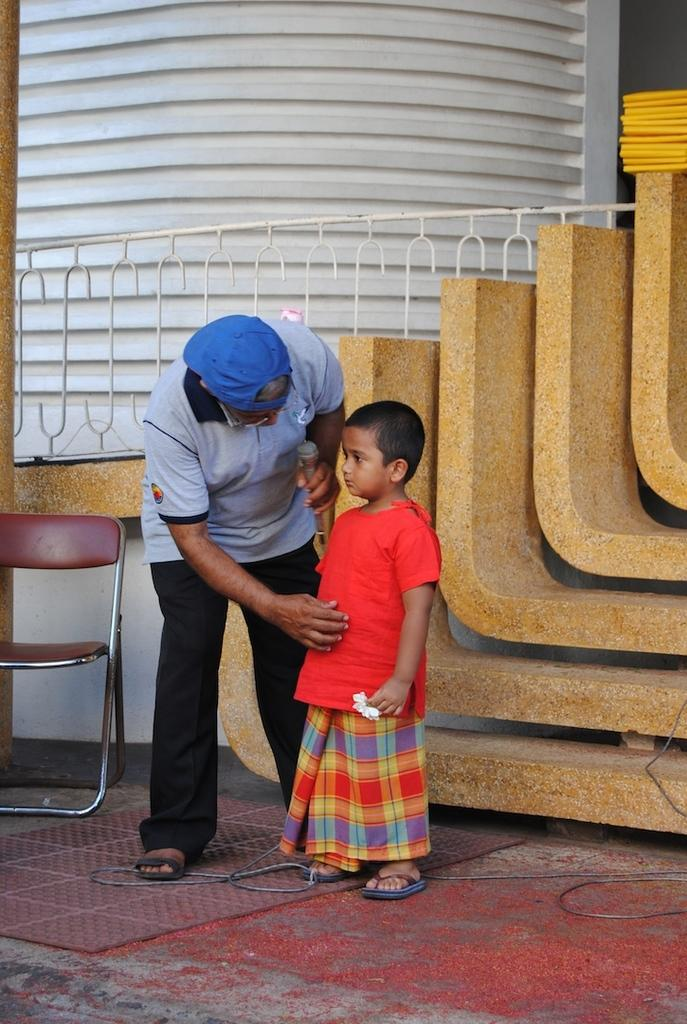Who is present in the image? There is a man and a child in the image. Where are the man and child located in the image? The man and child are on the left side of the image. What can be seen in the background of the image? There is a chair and a building in the background of the image. What type of produce is being harvested by the man and child in the image? There is no produce or harvesting activity depicted in the image; it features a man and a child on the left side of the image. What button is being pressed by the man and child in the image? There is no button or pressing activity depicted in the image; it features a man and a child on the left side of the image. 